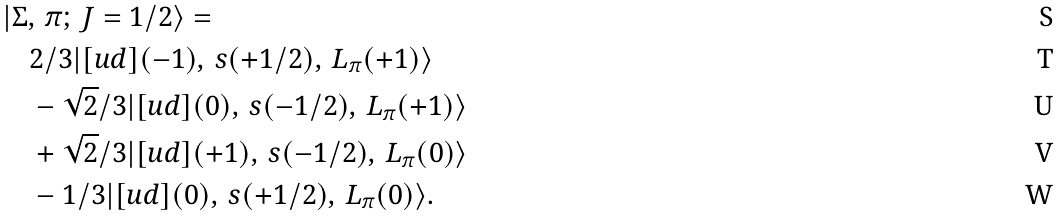Convert formula to latex. <formula><loc_0><loc_0><loc_500><loc_500>& | \Sigma , \, \pi ; \, J = 1 / 2 \rangle = \\ & \quad 2 / 3 | [ u d ] ( - 1 ) , \, s ( + 1 / 2 ) , \, L _ { \pi } ( + 1 ) \rangle \\ & \quad - \sqrt { 2 } / 3 | [ u d ] ( 0 ) , \, s ( - 1 / 2 ) , \, L _ { \pi } ( + 1 ) \rangle \\ & \quad + \sqrt { 2 } / 3 | [ u d ] ( + 1 ) , \, s ( - 1 / 2 ) , \, L _ { \pi } ( 0 ) \rangle \\ & \quad - 1 / 3 | [ u d ] ( 0 ) , \, s ( + 1 / 2 ) , \, L _ { \pi } ( 0 ) \rangle .</formula> 